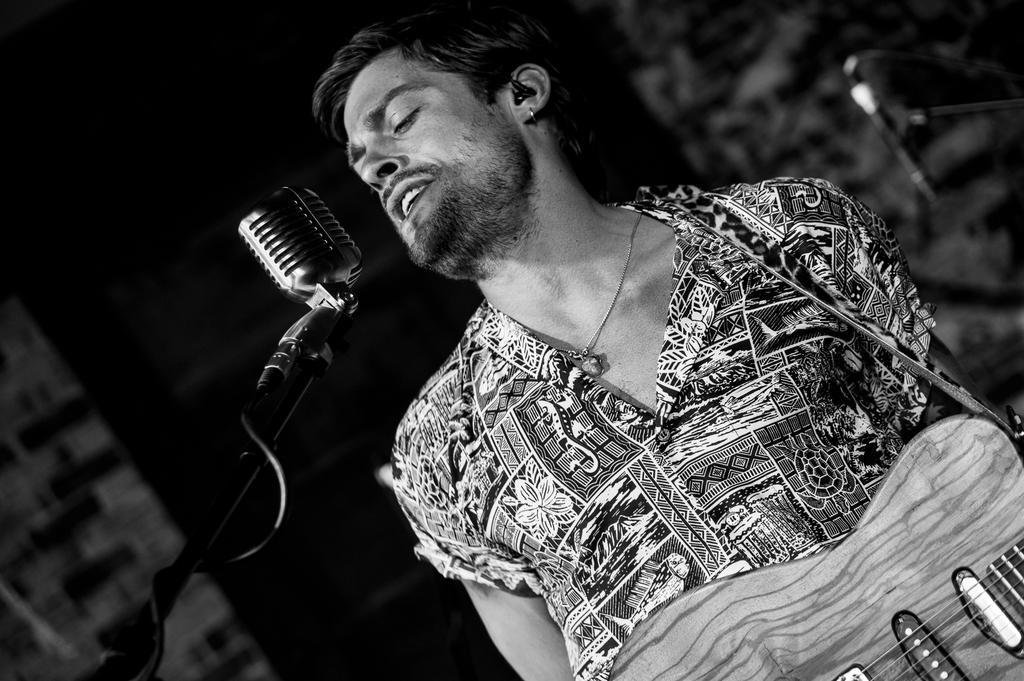Can you describe this image briefly? Here is a man who is singing on microphone and also holding a guitar. He wear a shirt. 